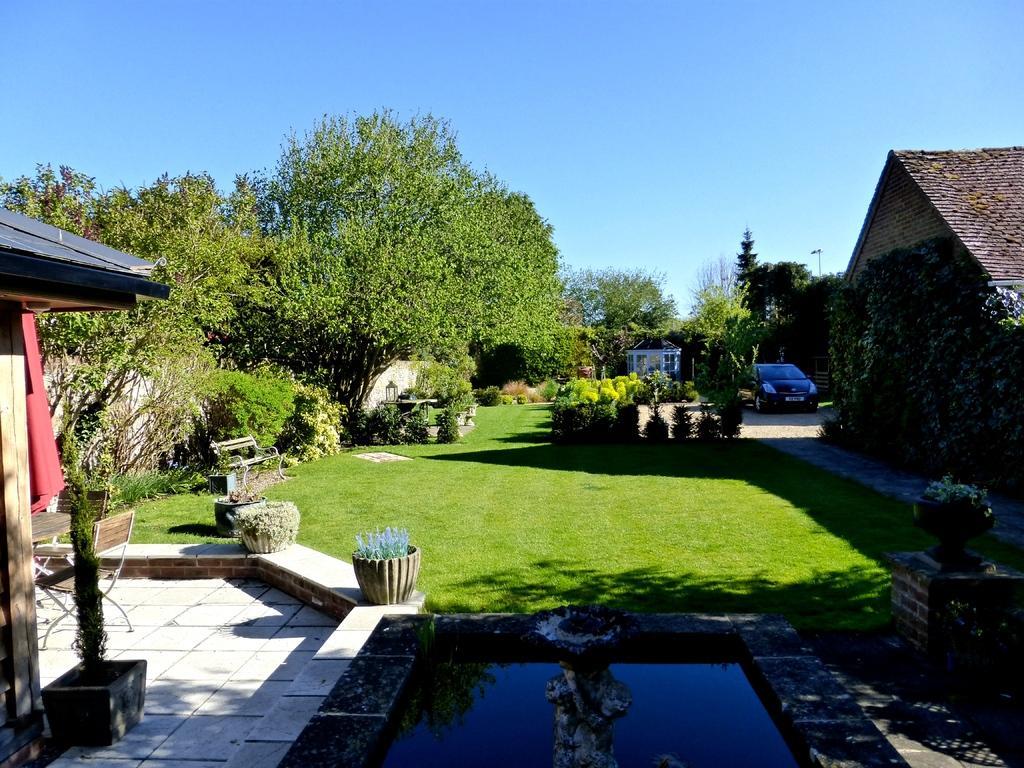How would you summarize this image in a sentence or two? In this picture I can see a vehicle, there are chairs, table, bench, plants, grass, trees, houses, water, and in the background there is sky. 